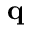Convert formula to latex. <formula><loc_0><loc_0><loc_500><loc_500>q</formula> 